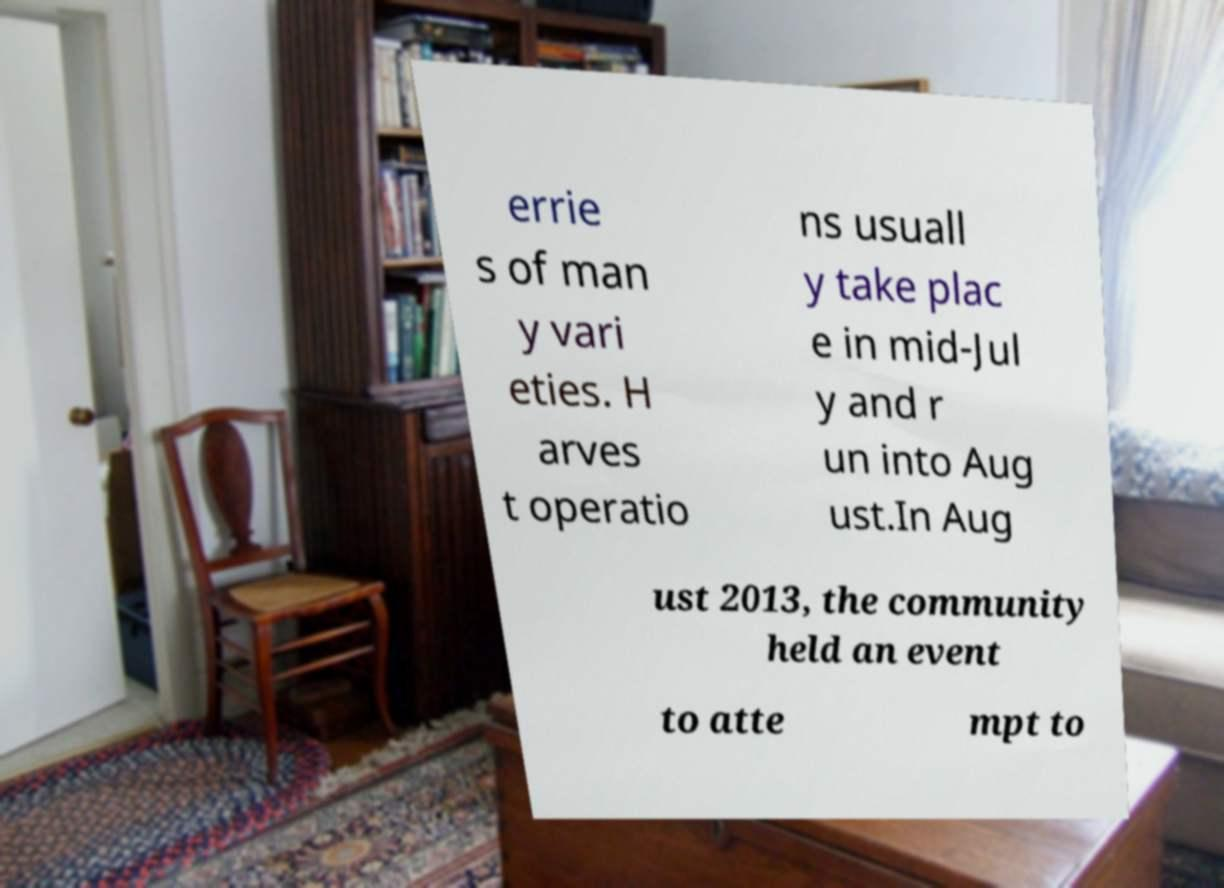Could you extract and type out the text from this image? errie s of man y vari eties. H arves t operatio ns usuall y take plac e in mid-Jul y and r un into Aug ust.In Aug ust 2013, the community held an event to atte mpt to 